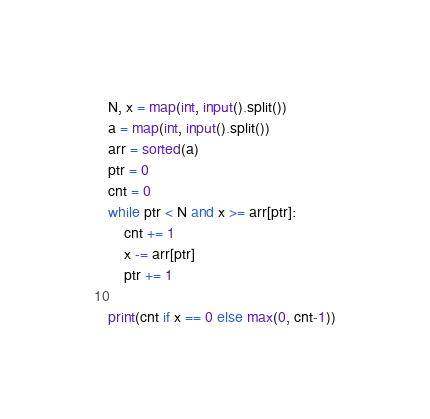Convert code to text. <code><loc_0><loc_0><loc_500><loc_500><_Python_>N, x = map(int, input().split())
a = map(int, input().split())
arr = sorted(a)
ptr = 0
cnt = 0
while ptr < N and x >= arr[ptr]:
	cnt += 1
	x -= arr[ptr]
	ptr += 1
	
print(cnt if x == 0 else max(0, cnt-1))</code> 